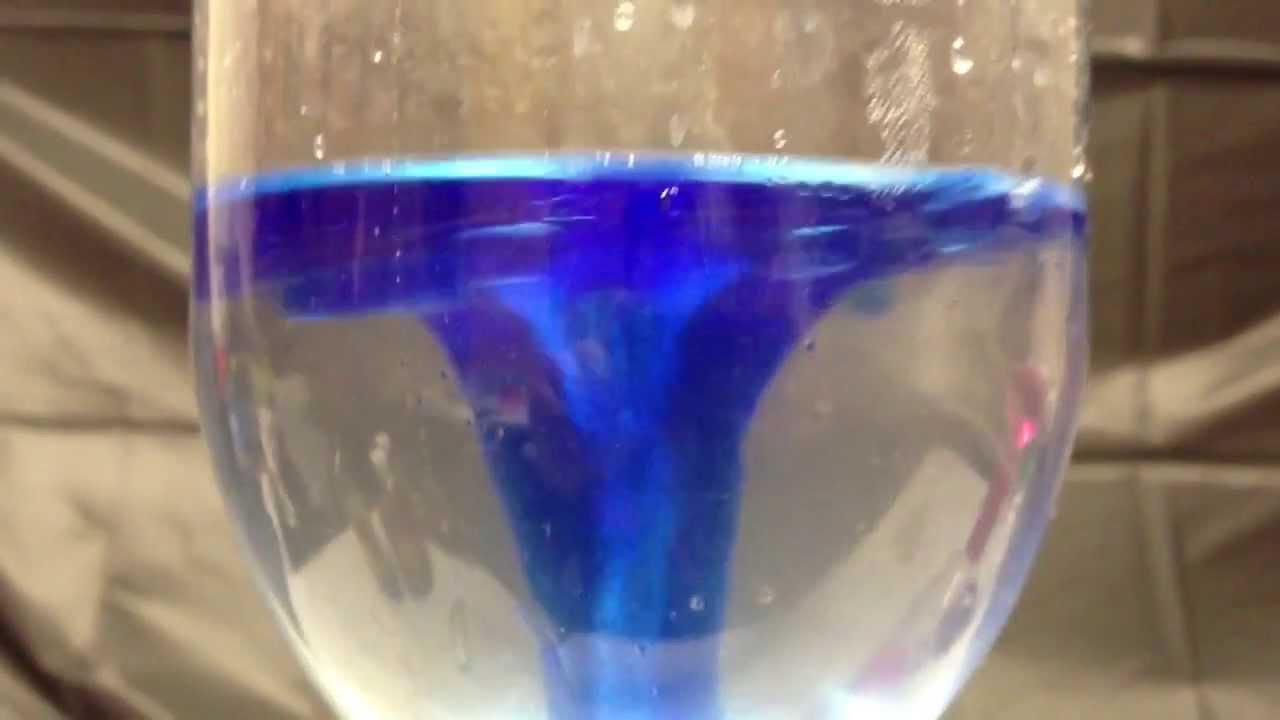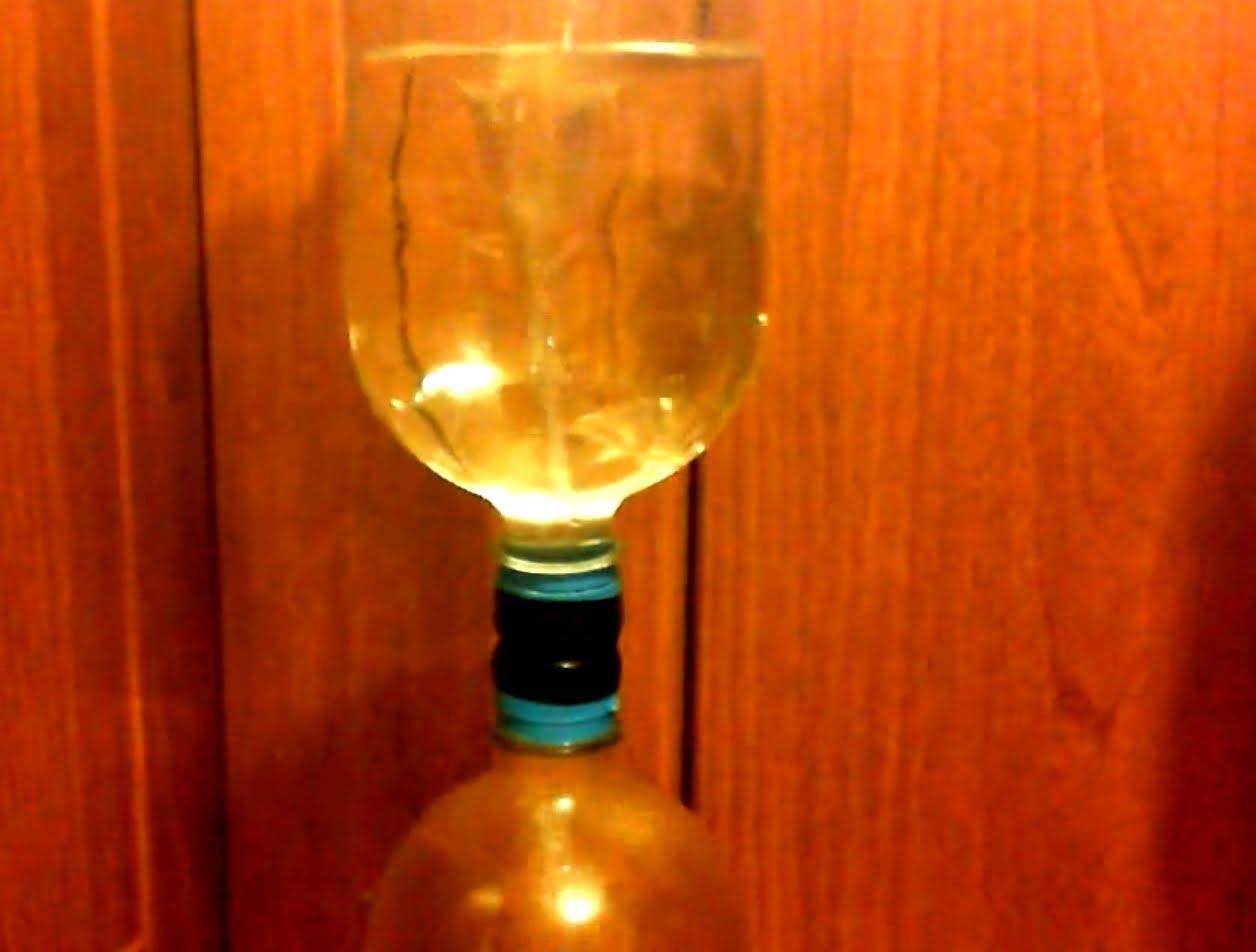The first image is the image on the left, the second image is the image on the right. Examine the images to the left and right. Is the description "One of the containers contains blue liquid." accurate? Answer yes or no. Yes. The first image is the image on the left, the second image is the image on the right. Analyze the images presented: Is the assertion "In at least one image there is a make shift blue bottle funnel creating a mini tornado in blue water." valid? Answer yes or no. Yes. 